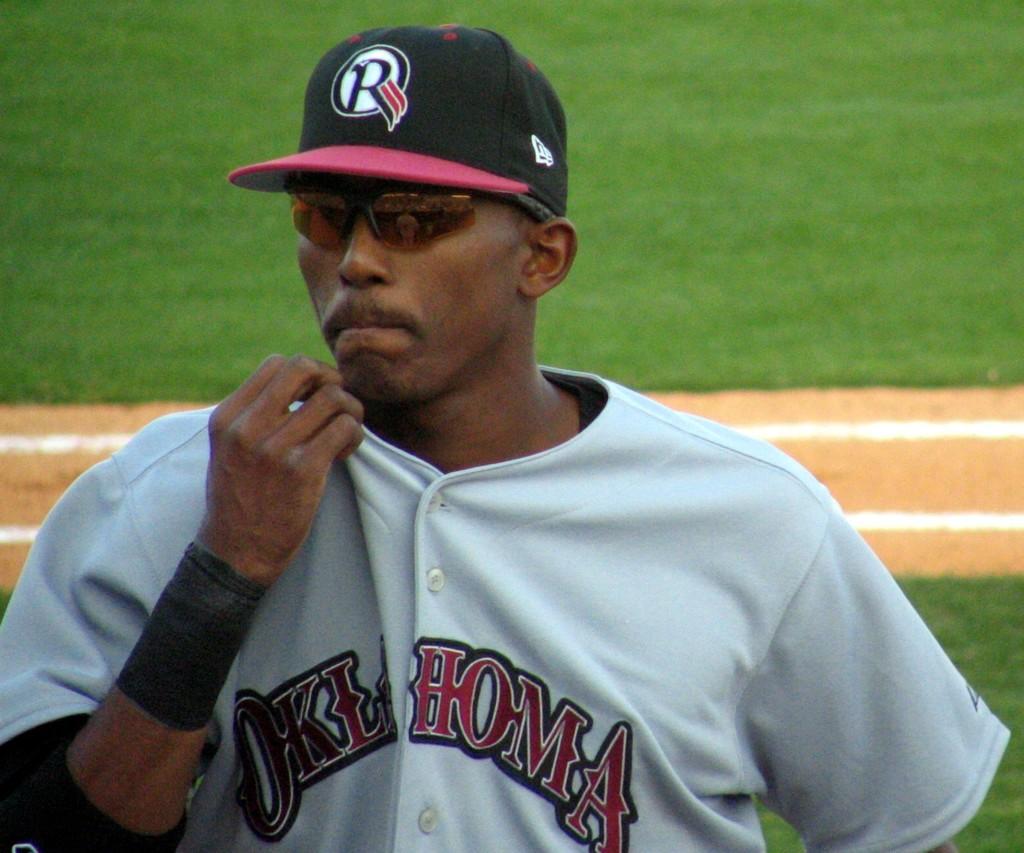What state is that player from?
Offer a very short reply. Oklahoma. What letter is on the players cap?
Offer a very short reply. R. 